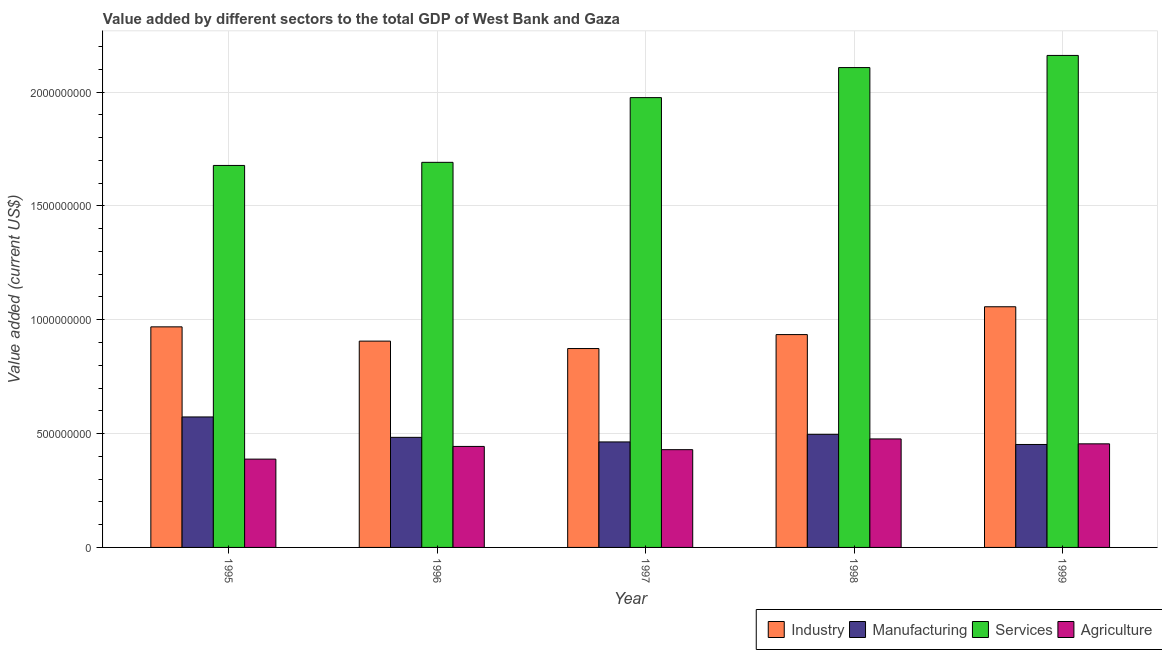Are the number of bars per tick equal to the number of legend labels?
Give a very brief answer. Yes. How many bars are there on the 2nd tick from the left?
Give a very brief answer. 4. How many bars are there on the 5th tick from the right?
Your answer should be very brief. 4. In how many cases, is the number of bars for a given year not equal to the number of legend labels?
Keep it short and to the point. 0. What is the value added by agricultural sector in 1996?
Offer a terse response. 4.44e+08. Across all years, what is the maximum value added by services sector?
Offer a terse response. 2.16e+09. Across all years, what is the minimum value added by manufacturing sector?
Give a very brief answer. 4.52e+08. What is the total value added by manufacturing sector in the graph?
Give a very brief answer. 2.47e+09. What is the difference between the value added by services sector in 1997 and that in 1999?
Provide a succinct answer. -1.85e+08. What is the difference between the value added by services sector in 1997 and the value added by agricultural sector in 1999?
Ensure brevity in your answer.  -1.85e+08. What is the average value added by industrial sector per year?
Your response must be concise. 9.48e+08. In the year 1996, what is the difference between the value added by industrial sector and value added by manufacturing sector?
Offer a terse response. 0. In how many years, is the value added by manufacturing sector greater than 900000000 US$?
Provide a short and direct response. 0. What is the ratio of the value added by agricultural sector in 1997 to that in 1998?
Offer a very short reply. 0.9. Is the difference between the value added by agricultural sector in 1995 and 1996 greater than the difference between the value added by services sector in 1995 and 1996?
Offer a terse response. No. What is the difference between the highest and the second highest value added by services sector?
Your answer should be compact. 5.33e+07. What is the difference between the highest and the lowest value added by agricultural sector?
Your answer should be compact. 8.87e+07. In how many years, is the value added by services sector greater than the average value added by services sector taken over all years?
Offer a terse response. 3. Is the sum of the value added by manufacturing sector in 1997 and 1998 greater than the maximum value added by agricultural sector across all years?
Your answer should be very brief. Yes. What does the 1st bar from the left in 1998 represents?
Ensure brevity in your answer.  Industry. What does the 3rd bar from the right in 1997 represents?
Offer a terse response. Manufacturing. Are all the bars in the graph horizontal?
Your answer should be very brief. No. Are the values on the major ticks of Y-axis written in scientific E-notation?
Offer a terse response. No. Does the graph contain any zero values?
Offer a very short reply. No. Does the graph contain grids?
Your answer should be compact. Yes. Where does the legend appear in the graph?
Provide a short and direct response. Bottom right. What is the title of the graph?
Your answer should be compact. Value added by different sectors to the total GDP of West Bank and Gaza. Does "Social Assistance" appear as one of the legend labels in the graph?
Your response must be concise. No. What is the label or title of the X-axis?
Your answer should be compact. Year. What is the label or title of the Y-axis?
Offer a very short reply. Value added (current US$). What is the Value added (current US$) in Industry in 1995?
Offer a very short reply. 9.69e+08. What is the Value added (current US$) in Manufacturing in 1995?
Your answer should be compact. 5.73e+08. What is the Value added (current US$) in Services in 1995?
Provide a short and direct response. 1.68e+09. What is the Value added (current US$) of Agriculture in 1995?
Offer a very short reply. 3.88e+08. What is the Value added (current US$) in Industry in 1996?
Provide a short and direct response. 9.06e+08. What is the Value added (current US$) of Manufacturing in 1996?
Offer a very short reply. 4.83e+08. What is the Value added (current US$) in Services in 1996?
Make the answer very short. 1.69e+09. What is the Value added (current US$) in Agriculture in 1996?
Provide a short and direct response. 4.44e+08. What is the Value added (current US$) of Industry in 1997?
Offer a terse response. 8.73e+08. What is the Value added (current US$) of Manufacturing in 1997?
Your answer should be very brief. 4.63e+08. What is the Value added (current US$) of Services in 1997?
Ensure brevity in your answer.  1.98e+09. What is the Value added (current US$) in Agriculture in 1997?
Offer a very short reply. 4.29e+08. What is the Value added (current US$) in Industry in 1998?
Provide a succinct answer. 9.35e+08. What is the Value added (current US$) in Manufacturing in 1998?
Provide a succinct answer. 4.97e+08. What is the Value added (current US$) in Services in 1998?
Ensure brevity in your answer.  2.11e+09. What is the Value added (current US$) in Agriculture in 1998?
Provide a succinct answer. 4.76e+08. What is the Value added (current US$) of Industry in 1999?
Provide a short and direct response. 1.06e+09. What is the Value added (current US$) in Manufacturing in 1999?
Your answer should be very brief. 4.52e+08. What is the Value added (current US$) of Services in 1999?
Ensure brevity in your answer.  2.16e+09. What is the Value added (current US$) in Agriculture in 1999?
Your response must be concise. 4.55e+08. Across all years, what is the maximum Value added (current US$) in Industry?
Your answer should be very brief. 1.06e+09. Across all years, what is the maximum Value added (current US$) of Manufacturing?
Your answer should be very brief. 5.73e+08. Across all years, what is the maximum Value added (current US$) in Services?
Offer a terse response. 2.16e+09. Across all years, what is the maximum Value added (current US$) of Agriculture?
Make the answer very short. 4.76e+08. Across all years, what is the minimum Value added (current US$) of Industry?
Your answer should be very brief. 8.73e+08. Across all years, what is the minimum Value added (current US$) of Manufacturing?
Provide a short and direct response. 4.52e+08. Across all years, what is the minimum Value added (current US$) in Services?
Provide a succinct answer. 1.68e+09. Across all years, what is the minimum Value added (current US$) in Agriculture?
Keep it short and to the point. 3.88e+08. What is the total Value added (current US$) in Industry in the graph?
Your answer should be compact. 4.74e+09. What is the total Value added (current US$) of Manufacturing in the graph?
Your answer should be compact. 2.47e+09. What is the total Value added (current US$) of Services in the graph?
Your response must be concise. 9.61e+09. What is the total Value added (current US$) in Agriculture in the graph?
Your response must be concise. 2.19e+09. What is the difference between the Value added (current US$) in Industry in 1995 and that in 1996?
Ensure brevity in your answer.  6.27e+07. What is the difference between the Value added (current US$) of Manufacturing in 1995 and that in 1996?
Offer a terse response. 8.96e+07. What is the difference between the Value added (current US$) in Services in 1995 and that in 1996?
Your answer should be compact. -1.36e+07. What is the difference between the Value added (current US$) in Agriculture in 1995 and that in 1996?
Your answer should be very brief. -5.57e+07. What is the difference between the Value added (current US$) in Industry in 1995 and that in 1997?
Your answer should be very brief. 9.53e+07. What is the difference between the Value added (current US$) of Manufacturing in 1995 and that in 1997?
Make the answer very short. 1.10e+08. What is the difference between the Value added (current US$) of Services in 1995 and that in 1997?
Your response must be concise. -2.98e+08. What is the difference between the Value added (current US$) of Agriculture in 1995 and that in 1997?
Give a very brief answer. -4.15e+07. What is the difference between the Value added (current US$) in Industry in 1995 and that in 1998?
Your response must be concise. 3.40e+07. What is the difference between the Value added (current US$) in Manufacturing in 1995 and that in 1998?
Provide a short and direct response. 7.64e+07. What is the difference between the Value added (current US$) in Services in 1995 and that in 1998?
Your answer should be compact. -4.30e+08. What is the difference between the Value added (current US$) of Agriculture in 1995 and that in 1998?
Offer a terse response. -8.87e+07. What is the difference between the Value added (current US$) of Industry in 1995 and that in 1999?
Offer a very short reply. -8.82e+07. What is the difference between the Value added (current US$) of Manufacturing in 1995 and that in 1999?
Keep it short and to the point. 1.21e+08. What is the difference between the Value added (current US$) in Services in 1995 and that in 1999?
Ensure brevity in your answer.  -4.83e+08. What is the difference between the Value added (current US$) in Agriculture in 1995 and that in 1999?
Provide a succinct answer. -6.71e+07. What is the difference between the Value added (current US$) in Industry in 1996 and that in 1997?
Offer a terse response. 3.26e+07. What is the difference between the Value added (current US$) of Manufacturing in 1996 and that in 1997?
Your answer should be compact. 2.01e+07. What is the difference between the Value added (current US$) of Services in 1996 and that in 1997?
Your answer should be compact. -2.84e+08. What is the difference between the Value added (current US$) in Agriculture in 1996 and that in 1997?
Your answer should be compact. 1.42e+07. What is the difference between the Value added (current US$) in Industry in 1996 and that in 1998?
Ensure brevity in your answer.  -2.87e+07. What is the difference between the Value added (current US$) of Manufacturing in 1996 and that in 1998?
Your answer should be compact. -1.32e+07. What is the difference between the Value added (current US$) of Services in 1996 and that in 1998?
Keep it short and to the point. -4.16e+08. What is the difference between the Value added (current US$) in Agriculture in 1996 and that in 1998?
Offer a terse response. -3.29e+07. What is the difference between the Value added (current US$) in Industry in 1996 and that in 1999?
Your answer should be very brief. -1.51e+08. What is the difference between the Value added (current US$) of Manufacturing in 1996 and that in 1999?
Your response must be concise. 3.13e+07. What is the difference between the Value added (current US$) of Services in 1996 and that in 1999?
Your answer should be very brief. -4.70e+08. What is the difference between the Value added (current US$) in Agriculture in 1996 and that in 1999?
Provide a short and direct response. -1.14e+07. What is the difference between the Value added (current US$) of Industry in 1997 and that in 1998?
Ensure brevity in your answer.  -6.13e+07. What is the difference between the Value added (current US$) in Manufacturing in 1997 and that in 1998?
Provide a succinct answer. -3.33e+07. What is the difference between the Value added (current US$) in Services in 1997 and that in 1998?
Your answer should be compact. -1.32e+08. What is the difference between the Value added (current US$) in Agriculture in 1997 and that in 1998?
Provide a short and direct response. -4.72e+07. What is the difference between the Value added (current US$) in Industry in 1997 and that in 1999?
Keep it short and to the point. -1.84e+08. What is the difference between the Value added (current US$) of Manufacturing in 1997 and that in 1999?
Your answer should be very brief. 1.12e+07. What is the difference between the Value added (current US$) of Services in 1997 and that in 1999?
Make the answer very short. -1.85e+08. What is the difference between the Value added (current US$) in Agriculture in 1997 and that in 1999?
Provide a succinct answer. -2.56e+07. What is the difference between the Value added (current US$) of Industry in 1998 and that in 1999?
Your answer should be very brief. -1.22e+08. What is the difference between the Value added (current US$) in Manufacturing in 1998 and that in 1999?
Ensure brevity in your answer.  4.46e+07. What is the difference between the Value added (current US$) in Services in 1998 and that in 1999?
Your answer should be very brief. -5.33e+07. What is the difference between the Value added (current US$) of Agriculture in 1998 and that in 1999?
Provide a short and direct response. 2.16e+07. What is the difference between the Value added (current US$) of Industry in 1995 and the Value added (current US$) of Manufacturing in 1996?
Give a very brief answer. 4.85e+08. What is the difference between the Value added (current US$) of Industry in 1995 and the Value added (current US$) of Services in 1996?
Your answer should be very brief. -7.23e+08. What is the difference between the Value added (current US$) of Industry in 1995 and the Value added (current US$) of Agriculture in 1996?
Ensure brevity in your answer.  5.25e+08. What is the difference between the Value added (current US$) in Manufacturing in 1995 and the Value added (current US$) in Services in 1996?
Provide a succinct answer. -1.12e+09. What is the difference between the Value added (current US$) in Manufacturing in 1995 and the Value added (current US$) in Agriculture in 1996?
Offer a terse response. 1.29e+08. What is the difference between the Value added (current US$) of Services in 1995 and the Value added (current US$) of Agriculture in 1996?
Offer a very short reply. 1.23e+09. What is the difference between the Value added (current US$) in Industry in 1995 and the Value added (current US$) in Manufacturing in 1997?
Provide a short and direct response. 5.05e+08. What is the difference between the Value added (current US$) in Industry in 1995 and the Value added (current US$) in Services in 1997?
Make the answer very short. -1.01e+09. What is the difference between the Value added (current US$) of Industry in 1995 and the Value added (current US$) of Agriculture in 1997?
Give a very brief answer. 5.39e+08. What is the difference between the Value added (current US$) in Manufacturing in 1995 and the Value added (current US$) in Services in 1997?
Keep it short and to the point. -1.40e+09. What is the difference between the Value added (current US$) of Manufacturing in 1995 and the Value added (current US$) of Agriculture in 1997?
Provide a succinct answer. 1.44e+08. What is the difference between the Value added (current US$) in Services in 1995 and the Value added (current US$) in Agriculture in 1997?
Make the answer very short. 1.25e+09. What is the difference between the Value added (current US$) in Industry in 1995 and the Value added (current US$) in Manufacturing in 1998?
Offer a very short reply. 4.72e+08. What is the difference between the Value added (current US$) of Industry in 1995 and the Value added (current US$) of Services in 1998?
Offer a terse response. -1.14e+09. What is the difference between the Value added (current US$) in Industry in 1995 and the Value added (current US$) in Agriculture in 1998?
Make the answer very short. 4.92e+08. What is the difference between the Value added (current US$) in Manufacturing in 1995 and the Value added (current US$) in Services in 1998?
Your response must be concise. -1.53e+09. What is the difference between the Value added (current US$) in Manufacturing in 1995 and the Value added (current US$) in Agriculture in 1998?
Offer a very short reply. 9.66e+07. What is the difference between the Value added (current US$) in Services in 1995 and the Value added (current US$) in Agriculture in 1998?
Your answer should be compact. 1.20e+09. What is the difference between the Value added (current US$) in Industry in 1995 and the Value added (current US$) in Manufacturing in 1999?
Make the answer very short. 5.17e+08. What is the difference between the Value added (current US$) in Industry in 1995 and the Value added (current US$) in Services in 1999?
Provide a succinct answer. -1.19e+09. What is the difference between the Value added (current US$) of Industry in 1995 and the Value added (current US$) of Agriculture in 1999?
Your response must be concise. 5.14e+08. What is the difference between the Value added (current US$) of Manufacturing in 1995 and the Value added (current US$) of Services in 1999?
Make the answer very short. -1.59e+09. What is the difference between the Value added (current US$) in Manufacturing in 1995 and the Value added (current US$) in Agriculture in 1999?
Your answer should be very brief. 1.18e+08. What is the difference between the Value added (current US$) of Services in 1995 and the Value added (current US$) of Agriculture in 1999?
Provide a succinct answer. 1.22e+09. What is the difference between the Value added (current US$) of Industry in 1996 and the Value added (current US$) of Manufacturing in 1997?
Give a very brief answer. 4.43e+08. What is the difference between the Value added (current US$) of Industry in 1996 and the Value added (current US$) of Services in 1997?
Your answer should be compact. -1.07e+09. What is the difference between the Value added (current US$) of Industry in 1996 and the Value added (current US$) of Agriculture in 1997?
Your answer should be very brief. 4.77e+08. What is the difference between the Value added (current US$) of Manufacturing in 1996 and the Value added (current US$) of Services in 1997?
Provide a short and direct response. -1.49e+09. What is the difference between the Value added (current US$) in Manufacturing in 1996 and the Value added (current US$) in Agriculture in 1997?
Your answer should be compact. 5.41e+07. What is the difference between the Value added (current US$) of Services in 1996 and the Value added (current US$) of Agriculture in 1997?
Offer a terse response. 1.26e+09. What is the difference between the Value added (current US$) in Industry in 1996 and the Value added (current US$) in Manufacturing in 1998?
Make the answer very short. 4.09e+08. What is the difference between the Value added (current US$) in Industry in 1996 and the Value added (current US$) in Services in 1998?
Offer a terse response. -1.20e+09. What is the difference between the Value added (current US$) in Industry in 1996 and the Value added (current US$) in Agriculture in 1998?
Offer a terse response. 4.30e+08. What is the difference between the Value added (current US$) in Manufacturing in 1996 and the Value added (current US$) in Services in 1998?
Provide a succinct answer. -1.62e+09. What is the difference between the Value added (current US$) in Manufacturing in 1996 and the Value added (current US$) in Agriculture in 1998?
Make the answer very short. 6.95e+06. What is the difference between the Value added (current US$) of Services in 1996 and the Value added (current US$) of Agriculture in 1998?
Give a very brief answer. 1.21e+09. What is the difference between the Value added (current US$) of Industry in 1996 and the Value added (current US$) of Manufacturing in 1999?
Your response must be concise. 4.54e+08. What is the difference between the Value added (current US$) of Industry in 1996 and the Value added (current US$) of Services in 1999?
Provide a short and direct response. -1.25e+09. What is the difference between the Value added (current US$) of Industry in 1996 and the Value added (current US$) of Agriculture in 1999?
Your answer should be very brief. 4.51e+08. What is the difference between the Value added (current US$) in Manufacturing in 1996 and the Value added (current US$) in Services in 1999?
Give a very brief answer. -1.68e+09. What is the difference between the Value added (current US$) in Manufacturing in 1996 and the Value added (current US$) in Agriculture in 1999?
Offer a very short reply. 2.85e+07. What is the difference between the Value added (current US$) of Services in 1996 and the Value added (current US$) of Agriculture in 1999?
Keep it short and to the point. 1.24e+09. What is the difference between the Value added (current US$) of Industry in 1997 and the Value added (current US$) of Manufacturing in 1998?
Ensure brevity in your answer.  3.77e+08. What is the difference between the Value added (current US$) of Industry in 1997 and the Value added (current US$) of Services in 1998?
Offer a very short reply. -1.23e+09. What is the difference between the Value added (current US$) of Industry in 1997 and the Value added (current US$) of Agriculture in 1998?
Ensure brevity in your answer.  3.97e+08. What is the difference between the Value added (current US$) of Manufacturing in 1997 and the Value added (current US$) of Services in 1998?
Make the answer very short. -1.64e+09. What is the difference between the Value added (current US$) of Manufacturing in 1997 and the Value added (current US$) of Agriculture in 1998?
Provide a succinct answer. -1.31e+07. What is the difference between the Value added (current US$) of Services in 1997 and the Value added (current US$) of Agriculture in 1998?
Provide a short and direct response. 1.50e+09. What is the difference between the Value added (current US$) in Industry in 1997 and the Value added (current US$) in Manufacturing in 1999?
Keep it short and to the point. 4.21e+08. What is the difference between the Value added (current US$) in Industry in 1997 and the Value added (current US$) in Services in 1999?
Your answer should be compact. -1.29e+09. What is the difference between the Value added (current US$) in Industry in 1997 and the Value added (current US$) in Agriculture in 1999?
Your answer should be compact. 4.19e+08. What is the difference between the Value added (current US$) in Manufacturing in 1997 and the Value added (current US$) in Services in 1999?
Keep it short and to the point. -1.70e+09. What is the difference between the Value added (current US$) of Manufacturing in 1997 and the Value added (current US$) of Agriculture in 1999?
Ensure brevity in your answer.  8.41e+06. What is the difference between the Value added (current US$) of Services in 1997 and the Value added (current US$) of Agriculture in 1999?
Offer a terse response. 1.52e+09. What is the difference between the Value added (current US$) of Industry in 1998 and the Value added (current US$) of Manufacturing in 1999?
Your answer should be compact. 4.83e+08. What is the difference between the Value added (current US$) in Industry in 1998 and the Value added (current US$) in Services in 1999?
Ensure brevity in your answer.  -1.23e+09. What is the difference between the Value added (current US$) of Industry in 1998 and the Value added (current US$) of Agriculture in 1999?
Provide a succinct answer. 4.80e+08. What is the difference between the Value added (current US$) in Manufacturing in 1998 and the Value added (current US$) in Services in 1999?
Give a very brief answer. -1.66e+09. What is the difference between the Value added (current US$) in Manufacturing in 1998 and the Value added (current US$) in Agriculture in 1999?
Your response must be concise. 4.18e+07. What is the difference between the Value added (current US$) in Services in 1998 and the Value added (current US$) in Agriculture in 1999?
Offer a terse response. 1.65e+09. What is the average Value added (current US$) in Industry per year?
Keep it short and to the point. 9.48e+08. What is the average Value added (current US$) of Manufacturing per year?
Your answer should be compact. 4.94e+08. What is the average Value added (current US$) in Services per year?
Keep it short and to the point. 1.92e+09. What is the average Value added (current US$) of Agriculture per year?
Ensure brevity in your answer.  4.38e+08. In the year 1995, what is the difference between the Value added (current US$) of Industry and Value added (current US$) of Manufacturing?
Provide a short and direct response. 3.96e+08. In the year 1995, what is the difference between the Value added (current US$) in Industry and Value added (current US$) in Services?
Your answer should be compact. -7.09e+08. In the year 1995, what is the difference between the Value added (current US$) of Industry and Value added (current US$) of Agriculture?
Make the answer very short. 5.81e+08. In the year 1995, what is the difference between the Value added (current US$) in Manufacturing and Value added (current US$) in Services?
Your response must be concise. -1.10e+09. In the year 1995, what is the difference between the Value added (current US$) in Manufacturing and Value added (current US$) in Agriculture?
Provide a succinct answer. 1.85e+08. In the year 1995, what is the difference between the Value added (current US$) of Services and Value added (current US$) of Agriculture?
Offer a terse response. 1.29e+09. In the year 1996, what is the difference between the Value added (current US$) in Industry and Value added (current US$) in Manufacturing?
Make the answer very short. 4.23e+08. In the year 1996, what is the difference between the Value added (current US$) in Industry and Value added (current US$) in Services?
Your answer should be very brief. -7.85e+08. In the year 1996, what is the difference between the Value added (current US$) of Industry and Value added (current US$) of Agriculture?
Your answer should be very brief. 4.63e+08. In the year 1996, what is the difference between the Value added (current US$) in Manufacturing and Value added (current US$) in Services?
Make the answer very short. -1.21e+09. In the year 1996, what is the difference between the Value added (current US$) in Manufacturing and Value added (current US$) in Agriculture?
Ensure brevity in your answer.  3.99e+07. In the year 1996, what is the difference between the Value added (current US$) in Services and Value added (current US$) in Agriculture?
Give a very brief answer. 1.25e+09. In the year 1997, what is the difference between the Value added (current US$) in Industry and Value added (current US$) in Manufacturing?
Your response must be concise. 4.10e+08. In the year 1997, what is the difference between the Value added (current US$) in Industry and Value added (current US$) in Services?
Make the answer very short. -1.10e+09. In the year 1997, what is the difference between the Value added (current US$) in Industry and Value added (current US$) in Agriculture?
Your answer should be very brief. 4.44e+08. In the year 1997, what is the difference between the Value added (current US$) of Manufacturing and Value added (current US$) of Services?
Ensure brevity in your answer.  -1.51e+09. In the year 1997, what is the difference between the Value added (current US$) in Manufacturing and Value added (current US$) in Agriculture?
Make the answer very short. 3.40e+07. In the year 1997, what is the difference between the Value added (current US$) in Services and Value added (current US$) in Agriculture?
Your answer should be very brief. 1.55e+09. In the year 1998, what is the difference between the Value added (current US$) of Industry and Value added (current US$) of Manufacturing?
Your answer should be compact. 4.38e+08. In the year 1998, what is the difference between the Value added (current US$) in Industry and Value added (current US$) in Services?
Offer a very short reply. -1.17e+09. In the year 1998, what is the difference between the Value added (current US$) of Industry and Value added (current US$) of Agriculture?
Make the answer very short. 4.58e+08. In the year 1998, what is the difference between the Value added (current US$) in Manufacturing and Value added (current US$) in Services?
Ensure brevity in your answer.  -1.61e+09. In the year 1998, what is the difference between the Value added (current US$) in Manufacturing and Value added (current US$) in Agriculture?
Provide a short and direct response. 2.02e+07. In the year 1998, what is the difference between the Value added (current US$) in Services and Value added (current US$) in Agriculture?
Your response must be concise. 1.63e+09. In the year 1999, what is the difference between the Value added (current US$) of Industry and Value added (current US$) of Manufacturing?
Make the answer very short. 6.05e+08. In the year 1999, what is the difference between the Value added (current US$) in Industry and Value added (current US$) in Services?
Provide a short and direct response. -1.10e+09. In the year 1999, what is the difference between the Value added (current US$) in Industry and Value added (current US$) in Agriculture?
Provide a succinct answer. 6.02e+08. In the year 1999, what is the difference between the Value added (current US$) of Manufacturing and Value added (current US$) of Services?
Your answer should be compact. -1.71e+09. In the year 1999, what is the difference between the Value added (current US$) of Manufacturing and Value added (current US$) of Agriculture?
Keep it short and to the point. -2.80e+06. In the year 1999, what is the difference between the Value added (current US$) of Services and Value added (current US$) of Agriculture?
Give a very brief answer. 1.71e+09. What is the ratio of the Value added (current US$) of Industry in 1995 to that in 1996?
Ensure brevity in your answer.  1.07. What is the ratio of the Value added (current US$) in Manufacturing in 1995 to that in 1996?
Ensure brevity in your answer.  1.19. What is the ratio of the Value added (current US$) in Services in 1995 to that in 1996?
Your answer should be compact. 0.99. What is the ratio of the Value added (current US$) in Agriculture in 1995 to that in 1996?
Give a very brief answer. 0.87. What is the ratio of the Value added (current US$) in Industry in 1995 to that in 1997?
Offer a very short reply. 1.11. What is the ratio of the Value added (current US$) of Manufacturing in 1995 to that in 1997?
Your answer should be very brief. 1.24. What is the ratio of the Value added (current US$) of Services in 1995 to that in 1997?
Give a very brief answer. 0.85. What is the ratio of the Value added (current US$) in Agriculture in 1995 to that in 1997?
Your answer should be very brief. 0.9. What is the ratio of the Value added (current US$) of Industry in 1995 to that in 1998?
Make the answer very short. 1.04. What is the ratio of the Value added (current US$) of Manufacturing in 1995 to that in 1998?
Make the answer very short. 1.15. What is the ratio of the Value added (current US$) of Services in 1995 to that in 1998?
Your answer should be very brief. 0.8. What is the ratio of the Value added (current US$) in Agriculture in 1995 to that in 1998?
Make the answer very short. 0.81. What is the ratio of the Value added (current US$) of Industry in 1995 to that in 1999?
Your response must be concise. 0.92. What is the ratio of the Value added (current US$) in Manufacturing in 1995 to that in 1999?
Keep it short and to the point. 1.27. What is the ratio of the Value added (current US$) of Services in 1995 to that in 1999?
Your answer should be compact. 0.78. What is the ratio of the Value added (current US$) of Agriculture in 1995 to that in 1999?
Offer a very short reply. 0.85. What is the ratio of the Value added (current US$) in Industry in 1996 to that in 1997?
Offer a very short reply. 1.04. What is the ratio of the Value added (current US$) of Manufacturing in 1996 to that in 1997?
Your response must be concise. 1.04. What is the ratio of the Value added (current US$) in Services in 1996 to that in 1997?
Provide a short and direct response. 0.86. What is the ratio of the Value added (current US$) of Agriculture in 1996 to that in 1997?
Provide a short and direct response. 1.03. What is the ratio of the Value added (current US$) in Industry in 1996 to that in 1998?
Ensure brevity in your answer.  0.97. What is the ratio of the Value added (current US$) of Manufacturing in 1996 to that in 1998?
Your answer should be very brief. 0.97. What is the ratio of the Value added (current US$) in Services in 1996 to that in 1998?
Offer a terse response. 0.8. What is the ratio of the Value added (current US$) of Agriculture in 1996 to that in 1998?
Provide a short and direct response. 0.93. What is the ratio of the Value added (current US$) in Industry in 1996 to that in 1999?
Your answer should be very brief. 0.86. What is the ratio of the Value added (current US$) of Manufacturing in 1996 to that in 1999?
Give a very brief answer. 1.07. What is the ratio of the Value added (current US$) of Services in 1996 to that in 1999?
Keep it short and to the point. 0.78. What is the ratio of the Value added (current US$) of Agriculture in 1996 to that in 1999?
Provide a short and direct response. 0.97. What is the ratio of the Value added (current US$) of Industry in 1997 to that in 1998?
Your answer should be very brief. 0.93. What is the ratio of the Value added (current US$) in Manufacturing in 1997 to that in 1998?
Give a very brief answer. 0.93. What is the ratio of the Value added (current US$) in Services in 1997 to that in 1998?
Provide a succinct answer. 0.94. What is the ratio of the Value added (current US$) in Agriculture in 1997 to that in 1998?
Make the answer very short. 0.9. What is the ratio of the Value added (current US$) in Industry in 1997 to that in 1999?
Offer a very short reply. 0.83. What is the ratio of the Value added (current US$) in Manufacturing in 1997 to that in 1999?
Provide a succinct answer. 1.02. What is the ratio of the Value added (current US$) of Services in 1997 to that in 1999?
Offer a very short reply. 0.91. What is the ratio of the Value added (current US$) in Agriculture in 1997 to that in 1999?
Your answer should be compact. 0.94. What is the ratio of the Value added (current US$) of Industry in 1998 to that in 1999?
Your answer should be very brief. 0.88. What is the ratio of the Value added (current US$) of Manufacturing in 1998 to that in 1999?
Keep it short and to the point. 1.1. What is the ratio of the Value added (current US$) in Services in 1998 to that in 1999?
Provide a succinct answer. 0.98. What is the ratio of the Value added (current US$) of Agriculture in 1998 to that in 1999?
Offer a very short reply. 1.05. What is the difference between the highest and the second highest Value added (current US$) in Industry?
Offer a very short reply. 8.82e+07. What is the difference between the highest and the second highest Value added (current US$) in Manufacturing?
Your answer should be compact. 7.64e+07. What is the difference between the highest and the second highest Value added (current US$) in Services?
Your answer should be very brief. 5.33e+07. What is the difference between the highest and the second highest Value added (current US$) in Agriculture?
Give a very brief answer. 2.16e+07. What is the difference between the highest and the lowest Value added (current US$) in Industry?
Keep it short and to the point. 1.84e+08. What is the difference between the highest and the lowest Value added (current US$) of Manufacturing?
Ensure brevity in your answer.  1.21e+08. What is the difference between the highest and the lowest Value added (current US$) in Services?
Your answer should be very brief. 4.83e+08. What is the difference between the highest and the lowest Value added (current US$) in Agriculture?
Your response must be concise. 8.87e+07. 